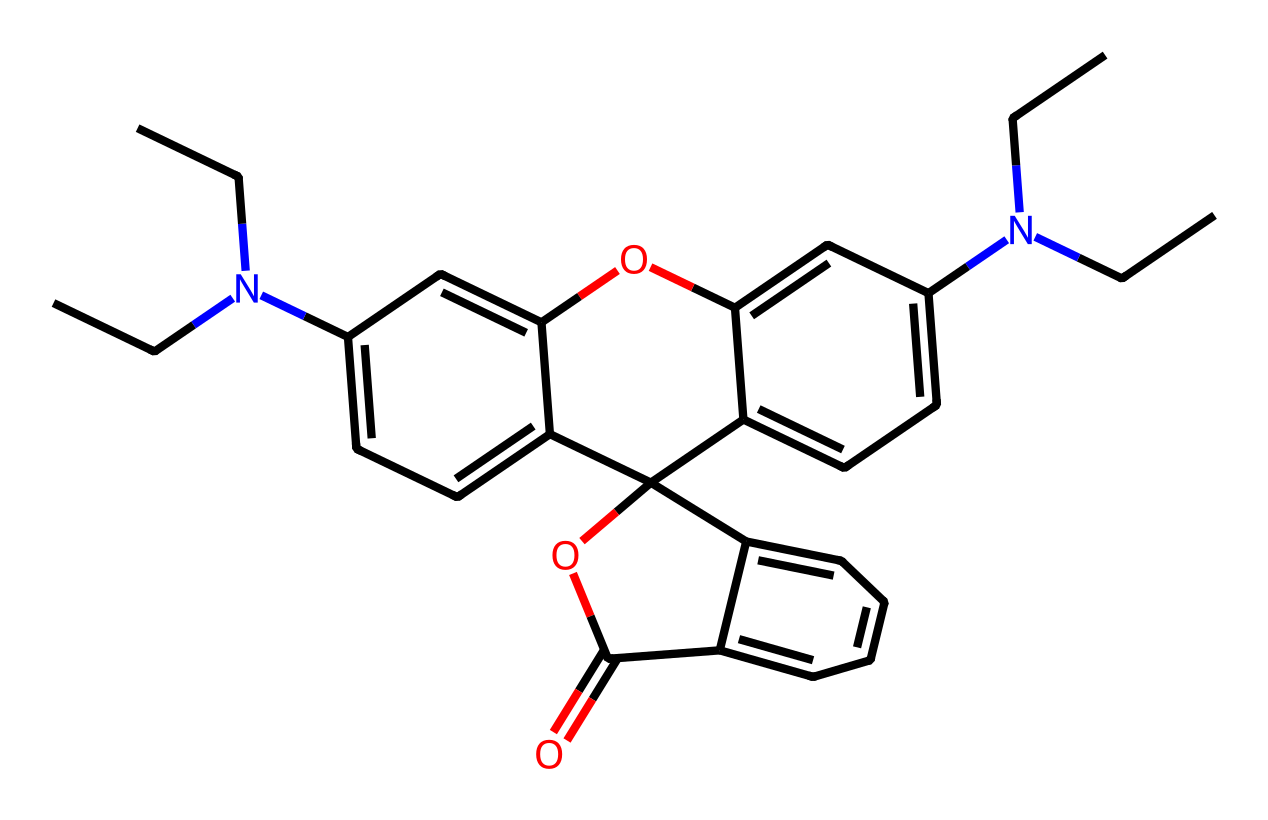What is the total number of nitrogen atoms in this structure? By analyzing the SMILES representation, we can identify each atom involved. The SMILES indicates two nitrogen atoms (N) present in the structure as they are directly mentioned.
Answer: two How many aromatic rings are present in this compound? To determine the number of aromatic rings, we look for fused benzene-like structures or distinct cyclic boundaries in the SMILES. This compound has multiple rings indicated by 'c' in the notation, which denotes carbon atoms in aromatic systems. Upon closer inspection, we see a total of two distinct fused aromatic rings.
Answer: two What type of functional group is represented by 'OC(=O)' in this chemical? The 'OC(=O)' portion represents an ester functional group, characterized by the 'C(=O)' notation which indicates a carbonyl group attached to an oxygen atom, thus outlining a common functional group in organic chemistry.
Answer: ester Does this compound contain any heteroatoms? Heteroatoms in organic compounds are atoms other than carbon and hydrogen. The presence of nitrogen and oxygen in the structure is confirmed through the SMILES representation. Thus, this compound contains heteroatoms.
Answer: yes What is the primary use of this type of chemical in cosmetics? Synthetic dyes like this compound are predominantly used for coloring because of their vibrant shades and stability, making them functional in product design particularly in cosmetics.
Answer: coloring What characteristic of this chemical allows it to impart vibrant colors? The presence of conjugated double bonds in the aromatic rings of this compound allows for the absorption of specific wavelengths of light, creating the appearance of vibrant colors, often utilized in dyes.
Answer: conjugation 